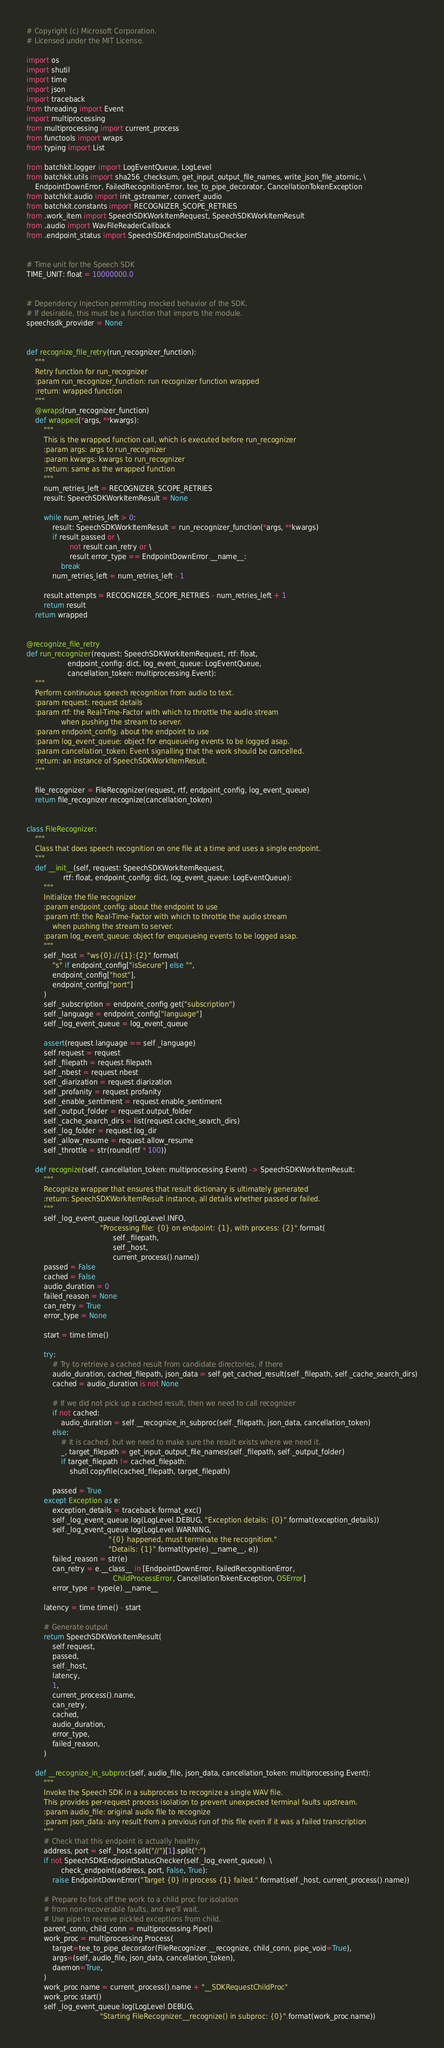<code> <loc_0><loc_0><loc_500><loc_500><_Python_># Copyright (c) Microsoft Corporation.
# Licensed under the MIT License.

import os
import shutil
import time
import json
import traceback
from threading import Event
import multiprocessing
from multiprocessing import current_process
from functools import wraps
from typing import List

from batchkit.logger import LogEventQueue, LogLevel
from batchkit.utils import sha256_checksum, get_input_output_file_names, write_json_file_atomic, \
    EndpointDownError, FailedRecognitionError, tee_to_pipe_decorator, CancellationTokenException
from batchkit.audio import init_gstreamer, convert_audio
from batchkit.constants import RECOGNIZER_SCOPE_RETRIES
from .work_item import SpeechSDKWorkItemRequest, SpeechSDKWorkItemResult
from .audio import WavFileReaderCallback
from .endpoint_status import SpeechSDKEndpointStatusChecker


# Time unit for the Speech SDK
TIME_UNIT: float = 10000000.0


# Dependency Injection permitting mocked behavior of the SDK.
# If desirable, this must be a function that imports the module.
speechsdk_provider = None


def recognize_file_retry(run_recognizer_function):
    """
    Retry function for run_recognizer
    :param run_recognizer_function: run recognizer function wrapped
    :return: wrapped function
    """
    @wraps(run_recognizer_function)
    def wrapped(*args, **kwargs):
        """
        This is the wrapped function call, which is executed before run_recognizer
        :param args: args to run_recognizer
        :param kwargs: kwargs to run_recognizer
        :return: same as the wrapped function
        """
        num_retries_left = RECOGNIZER_SCOPE_RETRIES
        result: SpeechSDKWorkItemResult = None

        while num_retries_left > 0:
            result: SpeechSDKWorkItemResult = run_recognizer_function(*args, **kwargs)
            if result.passed or \
                    not result.can_retry or \
                    result.error_type == EndpointDownError.__name__:
                break
            num_retries_left = num_retries_left - 1

        result.attempts = RECOGNIZER_SCOPE_RETRIES - num_retries_left + 1
        return result
    return wrapped


@recognize_file_retry
def run_recognizer(request: SpeechSDKWorkItemRequest, rtf: float,
                   endpoint_config: dict, log_event_queue: LogEventQueue,
                   cancellation_token: multiprocessing.Event):
    """
    Perform continuous speech recognition from audio to text.
    :param request: request details
    :param rtf: the Real-Time-Factor with which to throttle the audio stream
                when pushing the stream to server.
    :param endpoint_config: about the endpoint to use
    :param log_event_queue: object for enqueueing events to be logged asap.
    :param cancellation_token: Event signalling that the work should be cancelled.
    :return: an instance of SpeechSDKWorkItemResult.
    """

    file_recognizer = FileRecognizer(request, rtf, endpoint_config, log_event_queue)
    return file_recognizer.recognize(cancellation_token)


class FileRecognizer:
    """
    Class that does speech recognition on one file at a time and uses a single endpoint.
    """
    def __init__(self, request: SpeechSDKWorkItemRequest,
                 rtf: float, endpoint_config: dict, log_event_queue: LogEventQueue):
        """
        Initialize the file recognizer
        :param endpoint_config: about the endpoint to use
        :param rtf: the Real-Time-Factor with which to throttle the audio stream
            when pushing the stream to server.
        :param log_event_queue: object for enqueueing events to be logged asap.
        """
        self._host = "ws{0}://{1}:{2}".format(
            "s" if endpoint_config["isSecure"] else "",
            endpoint_config["host"],
            endpoint_config["port"]
        )
        self._subscription = endpoint_config.get("subscription")
        self._language = endpoint_config["language"]
        self._log_event_queue = log_event_queue

        assert(request.language == self._language)
        self.request = request
        self._filepath = request.filepath
        self._nbest = request.nbest
        self._diarization = request.diarization
        self._profanity = request.profanity
        self._enable_sentiment = request.enable_sentiment
        self._output_folder = request.output_folder
        self._cache_search_dirs = list(request.cache_search_dirs)
        self._log_folder = request.log_dir
        self._allow_resume = request.allow_resume
        self._throttle = str(round(rtf * 100))

    def recognize(self, cancellation_token: multiprocessing.Event) -> SpeechSDKWorkItemResult:
        """
        Recognize wrapper that ensures that result dictionary is ultimately generated
        :return: SpeechSDKWorkItemResult instance, all details whether passed or failed.
        """
        self._log_event_queue.log(LogLevel.INFO,
                                  "Processing file: {0} on endpoint: {1}, with process: {2}".format(
                                        self._filepath,
                                        self._host,
                                        current_process().name))
        passed = False
        cached = False
        audio_duration = 0
        failed_reason = None
        can_retry = True
        error_type = None

        start = time.time()

        try:
            # Try to retrieve a cached result from candidate directories, if there
            audio_duration, cached_filepath, json_data = self.get_cached_result(self._filepath, self._cache_search_dirs)
            cached = audio_duration is not None

            # If we did not pick up a cached result, then we need to call recognizer
            if not cached:
                audio_duration = self.__recognize_in_subproc(self._filepath, json_data, cancellation_token)
            else:
                # It is cached, but we need to make sure the result exists where we need it.
                _, target_filepath = get_input_output_file_names(self._filepath, self._output_folder)
                if target_filepath != cached_filepath:
                    shutil.copyfile(cached_filepath, target_filepath)

            passed = True
        except Exception as e:
            exception_details = traceback.format_exc()
            self._log_event_queue.log(LogLevel.DEBUG, "Exception details: {0}".format(exception_details))
            self._log_event_queue.log(LogLevel.WARNING,
                                      "{0} happened, must terminate the recognition."
                                      "Details: {1}".format(type(e).__name__, e))
            failed_reason = str(e)
            can_retry = e.__class__ in [EndpointDownError, FailedRecognitionError,
                                        ChildProcessError, CancellationTokenException, OSError]
            error_type = type(e).__name__

        latency = time.time() - start

        # Generate output
        return SpeechSDKWorkItemResult(
            self.request,
            passed,
            self._host,
            latency,
            1,
            current_process().name,
            can_retry,
            cached,
            audio_duration,
            error_type,
            failed_reason,
        )

    def __recognize_in_subproc(self, audio_file, json_data, cancellation_token: multiprocessing.Event):
        """
        Invoke the Speech SDK in a subprocess to recognize a single WAV file.
        This provides per-request process isolation to prevent unexpected terminal faults upstream.
        :param audio_file: original audio file to recognize
        :param json_data: any result from a previous run of this file even if it was a failed transcription
        """
        # Check that this endpoint is actually healthy.
        address, port = self._host.split("//")[1].split(":")
        if not SpeechSDKEndpointStatusChecker(self._log_event_queue). \
                check_endpoint(address, port, False, True):
            raise EndpointDownError("Target {0} in process {1} failed.".format(self._host, current_process().name))

        # Prepare to fork off the work to a child proc for isolation
        # from non-recoverable faults, and we'll wait.
        # Use pipe to receive pickled exceptions from child.
        parent_conn, child_conn = multiprocessing.Pipe()
        work_proc = multiprocessing.Process(
            target=tee_to_pipe_decorator(FileRecognizer.__recognize, child_conn, pipe_void=True),
            args=(self, audio_file, json_data, cancellation_token),
            daemon=True,
        )
        work_proc.name = current_process().name + "__SDKRequestChildProc"
        work_proc.start()
        self._log_event_queue.log(LogLevel.DEBUG,
                                  "Starting FileRecognizer.__recognize() in subproc: {0}".format(work_proc.name))
</code> 